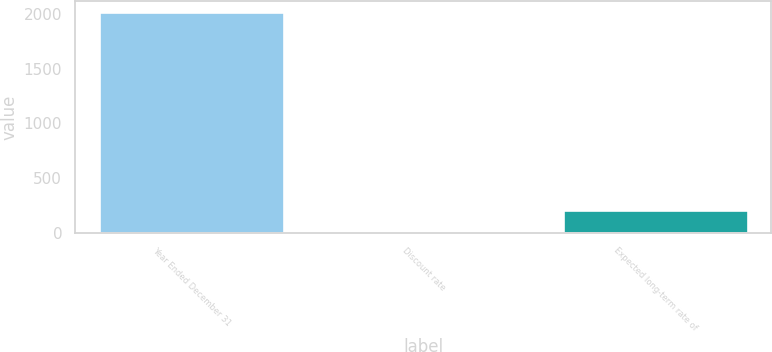Convert chart to OTSL. <chart><loc_0><loc_0><loc_500><loc_500><bar_chart><fcel>Year Ended December 31<fcel>Discount rate<fcel>Expected long-term rate of<nl><fcel>2016<fcel>4.25<fcel>205.43<nl></chart> 